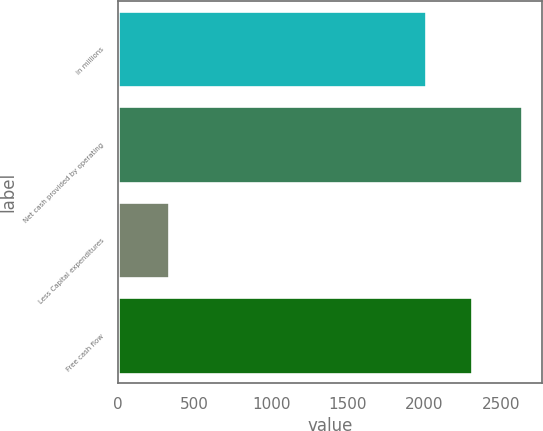Convert chart to OTSL. <chart><loc_0><loc_0><loc_500><loc_500><bar_chart><fcel>in millions<fcel>Net cash provided by operating<fcel>Less Capital expenditures<fcel>Free cash flow<nl><fcel>2012<fcel>2640<fcel>331<fcel>2309<nl></chart> 